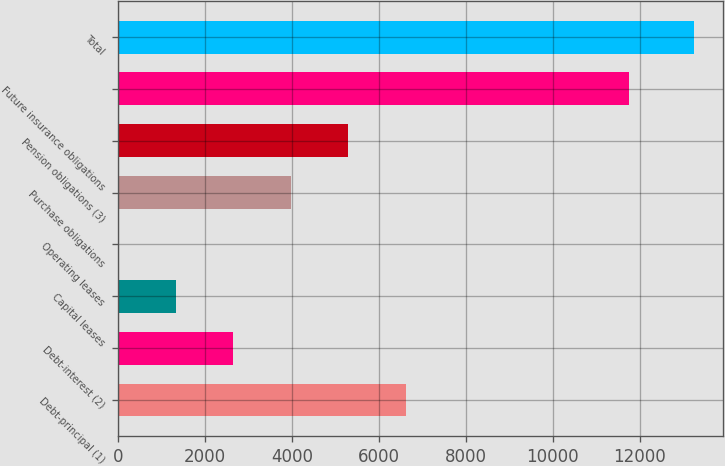<chart> <loc_0><loc_0><loc_500><loc_500><bar_chart><fcel>Debt-principal (1)<fcel>Debt-interest (2)<fcel>Capital leases<fcel>Operating leases<fcel>Purchase obligations<fcel>Pension obligations (3)<fcel>Future insurance obligations<fcel>Total<nl><fcel>6624.42<fcel>2650.29<fcel>1325.58<fcel>0.87<fcel>3975<fcel>5299.71<fcel>11750<fcel>13248<nl></chart> 